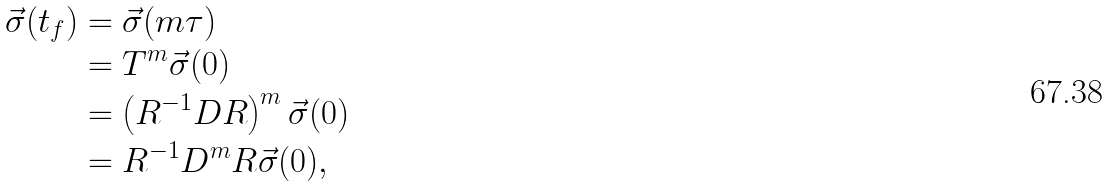<formula> <loc_0><loc_0><loc_500><loc_500>\vec { \sigma } ( t _ { f } ) & = \vec { \sigma } ( m \tau ) \\ & = T ^ { m } \vec { \sigma } ( 0 ) \\ & = \left ( R ^ { - 1 } D R \right ) ^ { m } \vec { \sigma } ( 0 ) \\ & = R ^ { - 1 } D ^ { m } R \vec { \sigma } ( 0 ) ,</formula> 